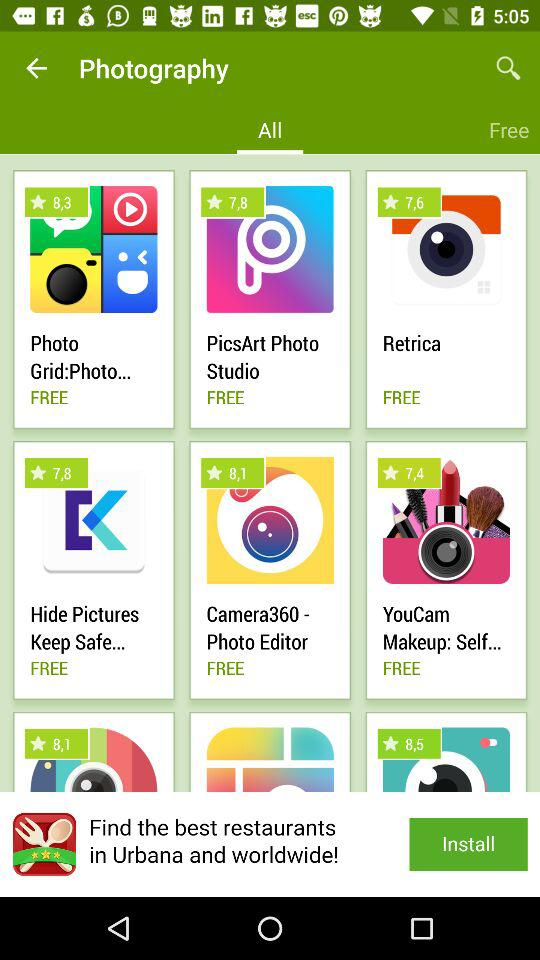What is the rating for the "YouCam Makeup: Selfie Camera" app? The rating is 7.4. 